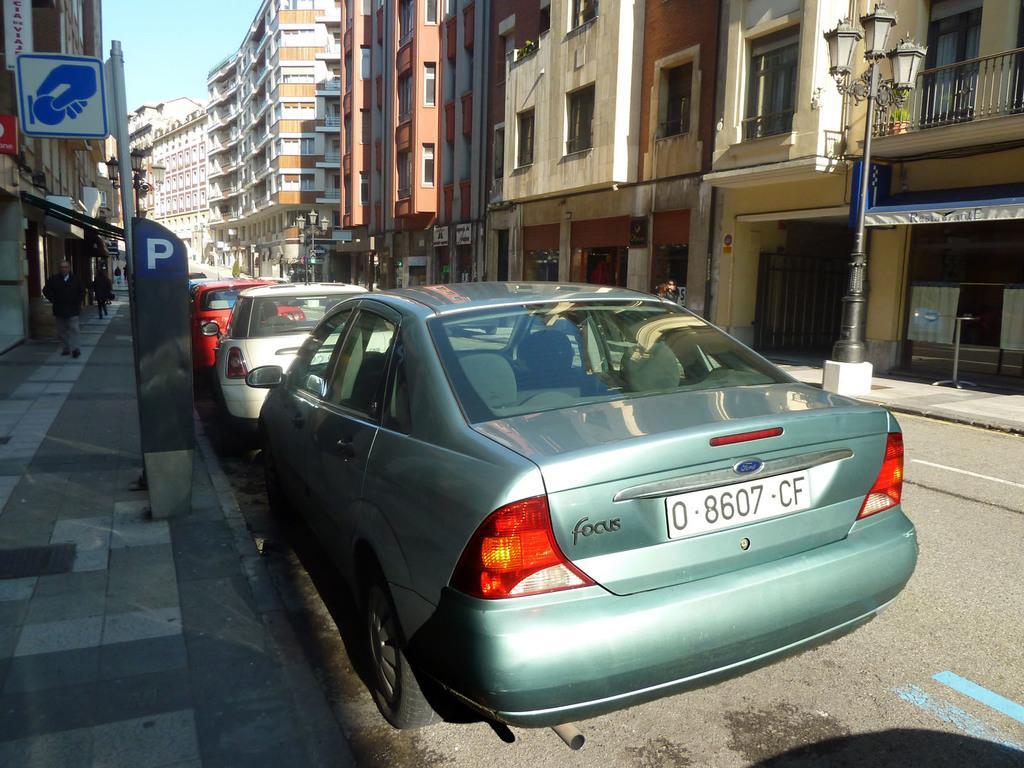How would you summarize this image in a sentence or two? This picture might be taken outside of the city and it is very sunny. In this image, in the middle, we can see few cars which are placed on the road. On the right side of the image, there are some street lights, footpath, buildings, windows. On the left side, we can also see some hoardings and group of people are walking on the foot path, buildings. On the top there is a sky, at the bottom there is a road. 